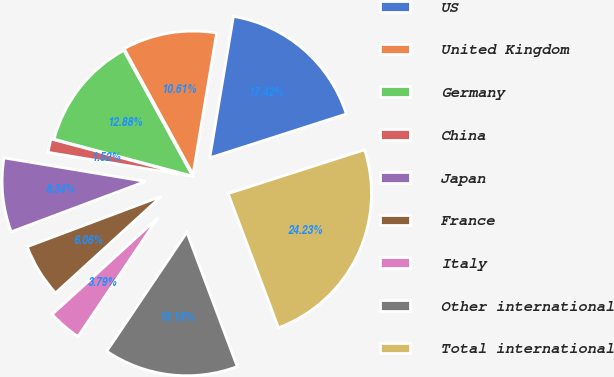Convert chart to OTSL. <chart><loc_0><loc_0><loc_500><loc_500><pie_chart><fcel>US<fcel>United Kingdom<fcel>Germany<fcel>China<fcel>Japan<fcel>France<fcel>Italy<fcel>Other international<fcel>Total international<nl><fcel>17.42%<fcel>10.61%<fcel>12.88%<fcel>1.52%<fcel>8.34%<fcel>6.06%<fcel>3.79%<fcel>15.15%<fcel>24.23%<nl></chart> 